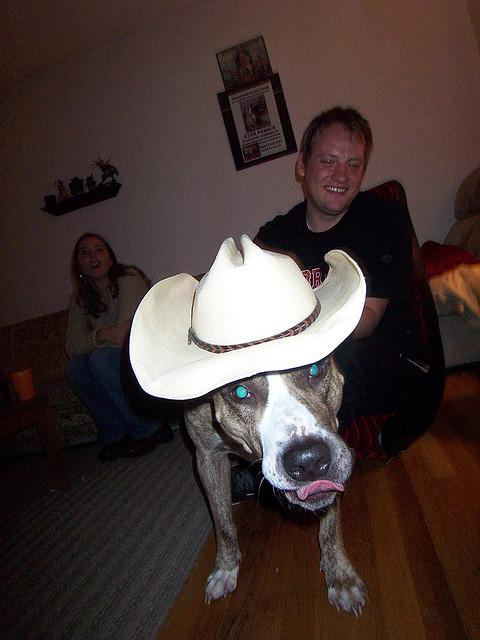Who put the hat on the dog?

Choices:
A) woman
B) cat
C) dog
D) man behind man behind 